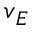Convert formula to latex. <formula><loc_0><loc_0><loc_500><loc_500>v _ { E }</formula> 